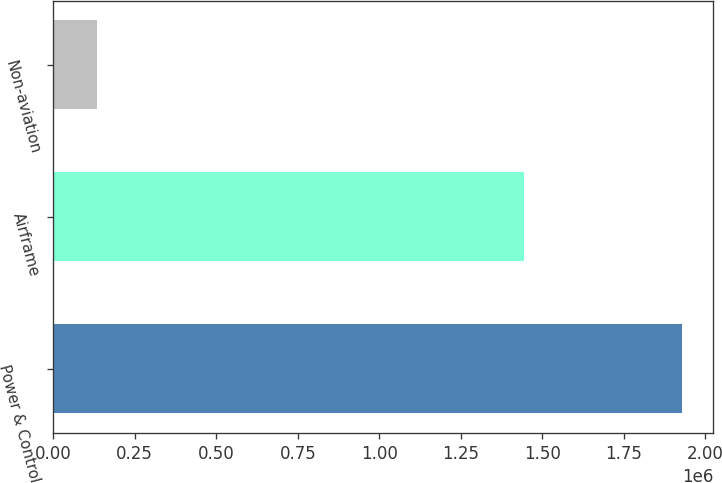Convert chart to OTSL. <chart><loc_0><loc_0><loc_500><loc_500><bar_chart><fcel>Power & Control<fcel>Airframe<fcel>Non-aviation<nl><fcel>1.92724e+06<fcel>1.44207e+06<fcel>134969<nl></chart> 